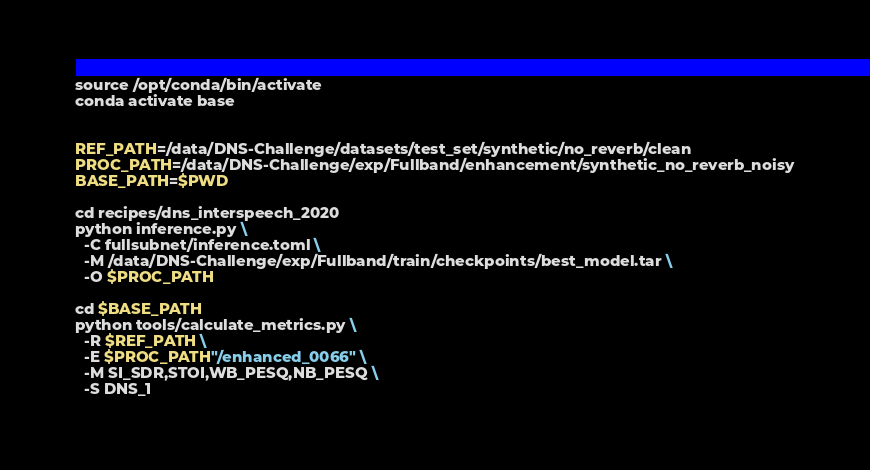<code> <loc_0><loc_0><loc_500><loc_500><_Bash_>source /opt/conda/bin/activate
conda activate base


REF_PATH=/data/DNS-Challenge/datasets/test_set/synthetic/no_reverb/clean
PROC_PATH=/data/DNS-Challenge/exp/Fullband/enhancement/synthetic_no_reverb_noisy
BASE_PATH=$PWD

cd recipes/dns_interspeech_2020
python inference.py \
  -C fullsubnet/inference.toml \
  -M /data/DNS-Challenge/exp/Fullband/train/checkpoints/best_model.tar \
  -O $PROC_PATH

cd $BASE_PATH
python tools/calculate_metrics.py \
  -R $REF_PATH \
  -E $PROC_PATH"/enhanced_0066" \
  -M SI_SDR,STOI,WB_PESQ,NB_PESQ \
  -S DNS_1</code> 